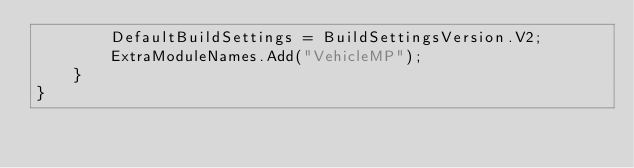Convert code to text. <code><loc_0><loc_0><loc_500><loc_500><_C#_>		DefaultBuildSettings = BuildSettingsVersion.V2;
		ExtraModuleNames.Add("VehicleMP");
	}
}
</code> 